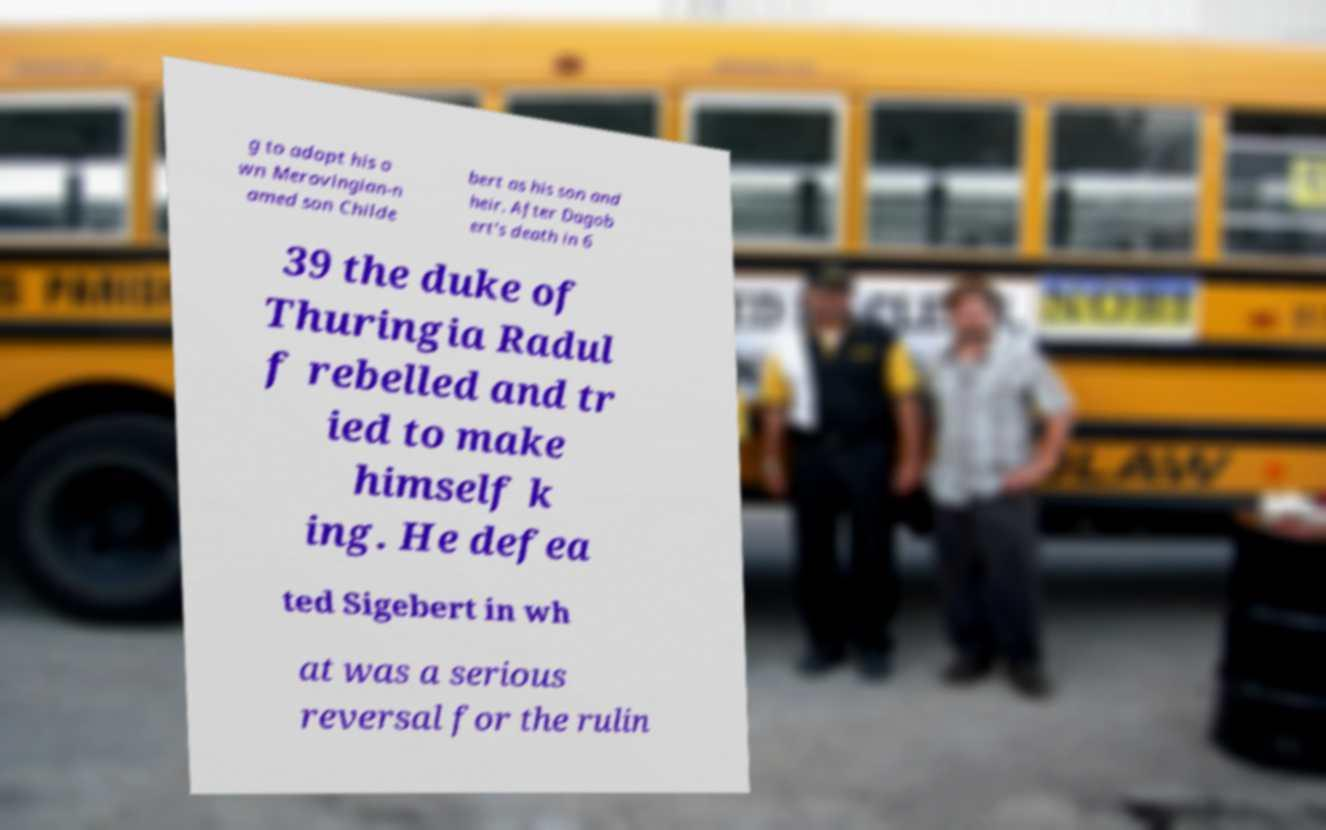Could you extract and type out the text from this image? g to adopt his o wn Merovingian-n amed son Childe bert as his son and heir. After Dagob ert's death in 6 39 the duke of Thuringia Radul f rebelled and tr ied to make himself k ing. He defea ted Sigebert in wh at was a serious reversal for the rulin 